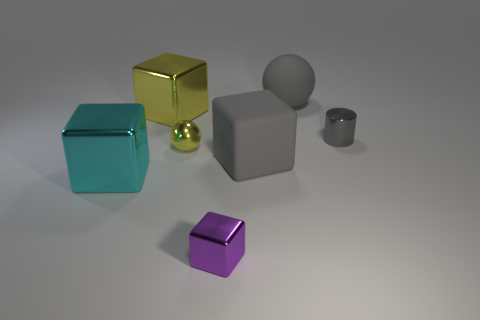There is a large object that is the same color as the tiny sphere; what is it made of?
Give a very brief answer. Metal. What is the size of the cylinder that is the same color as the big matte sphere?
Ensure brevity in your answer.  Small. Are there more large yellow objects than gray objects?
Offer a very short reply. No. There is a big gray thing in front of the object to the right of the sphere behind the tiny yellow object; what shape is it?
Provide a short and direct response. Cube. Is the block in front of the big cyan object made of the same material as the block that is on the right side of the purple metallic block?
Ensure brevity in your answer.  No. There is a tiny yellow object that is the same material as the tiny cylinder; what is its shape?
Make the answer very short. Sphere. Is there any other thing that is the same color as the tiny cube?
Offer a terse response. No. How many green cylinders are there?
Provide a succinct answer. 0. There is a big gray object that is in front of the sphere to the right of the small purple cube; what is it made of?
Ensure brevity in your answer.  Rubber. What color is the large shiny object behind the big shiny object left of the large metal thing that is on the right side of the cyan metallic block?
Your answer should be compact. Yellow. 